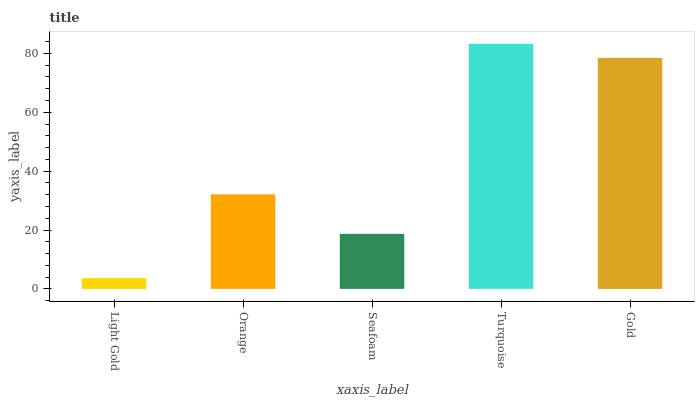Is Orange the minimum?
Answer yes or no. No. Is Orange the maximum?
Answer yes or no. No. Is Orange greater than Light Gold?
Answer yes or no. Yes. Is Light Gold less than Orange?
Answer yes or no. Yes. Is Light Gold greater than Orange?
Answer yes or no. No. Is Orange less than Light Gold?
Answer yes or no. No. Is Orange the high median?
Answer yes or no. Yes. Is Orange the low median?
Answer yes or no. Yes. Is Turquoise the high median?
Answer yes or no. No. Is Seafoam the low median?
Answer yes or no. No. 